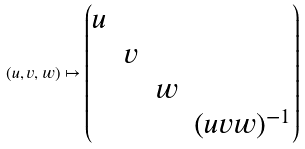<formula> <loc_0><loc_0><loc_500><loc_500>( u , v , w ) \mapsto \begin{pmatrix} u & & & \\ & v & & \\ & & w & \\ & & & ( u v w ) ^ { - 1 } \end{pmatrix}</formula> 